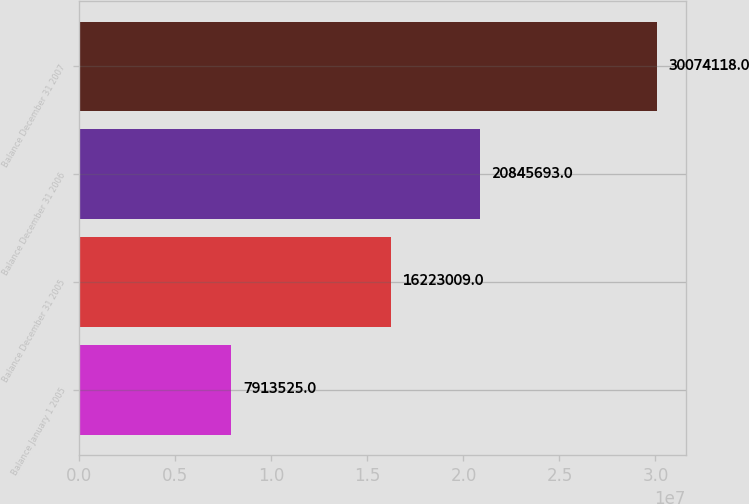<chart> <loc_0><loc_0><loc_500><loc_500><bar_chart><fcel>Balance January 1 2005<fcel>Balance December 31 2005<fcel>Balance December 31 2006<fcel>Balance December 31 2007<nl><fcel>7.91352e+06<fcel>1.6223e+07<fcel>2.08457e+07<fcel>3.00741e+07<nl></chart> 